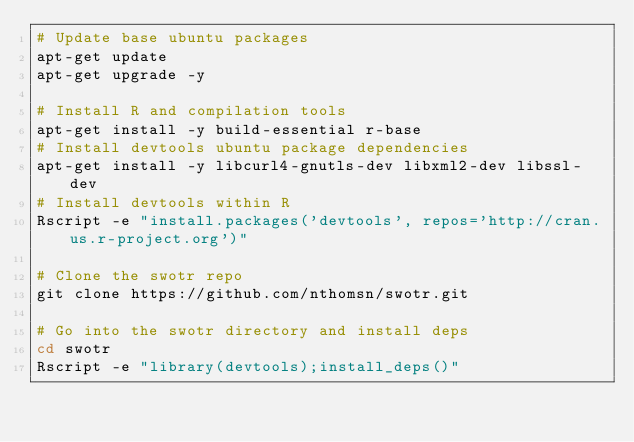<code> <loc_0><loc_0><loc_500><loc_500><_Bash_># Update base ubuntu packages
apt-get update
apt-get upgrade -y

# Install R and compilation tools
apt-get install -y build-essential r-base
# Install devtools ubuntu package dependencies
apt-get install -y libcurl4-gnutls-dev libxml2-dev libssl-dev
# Install devtools within R
Rscript -e "install.packages('devtools', repos='http://cran.us.r-project.org')"

# Clone the swotr repo
git clone https://github.com/nthomsn/swotr.git

# Go into the swotr directory and install deps
cd swotr
Rscript -e "library(devtools);install_deps()"
</code> 